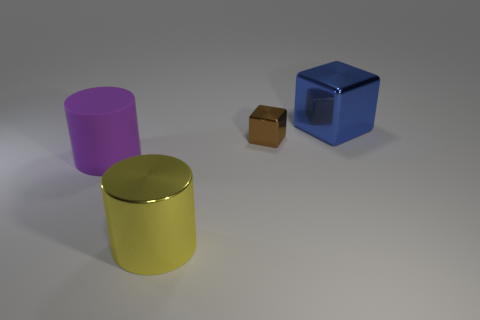Is there any other thing that has the same material as the big purple cylinder?
Keep it short and to the point. No. Is the size of the metal thing to the left of the small brown object the same as the cube that is to the left of the large cube?
Give a very brief answer. No. Is there any other thing that has the same size as the brown metallic thing?
Keep it short and to the point. No. What material is the big purple object that is the same shape as the big yellow metallic object?
Offer a very short reply. Rubber. There is a large shiny thing on the left side of the big blue thing; is its shape the same as the large metallic object that is to the right of the big yellow shiny cylinder?
Your answer should be compact. No. Is the number of large yellow shiny cylinders greater than the number of things?
Offer a very short reply. No. What is the size of the brown object?
Keep it short and to the point. Small. How many other things are there of the same color as the big matte cylinder?
Make the answer very short. 0. Does the block in front of the large block have the same material as the big blue thing?
Ensure brevity in your answer.  Yes. Are there fewer big things that are on the left side of the large matte cylinder than big blue blocks that are to the right of the tiny metal thing?
Ensure brevity in your answer.  Yes. 